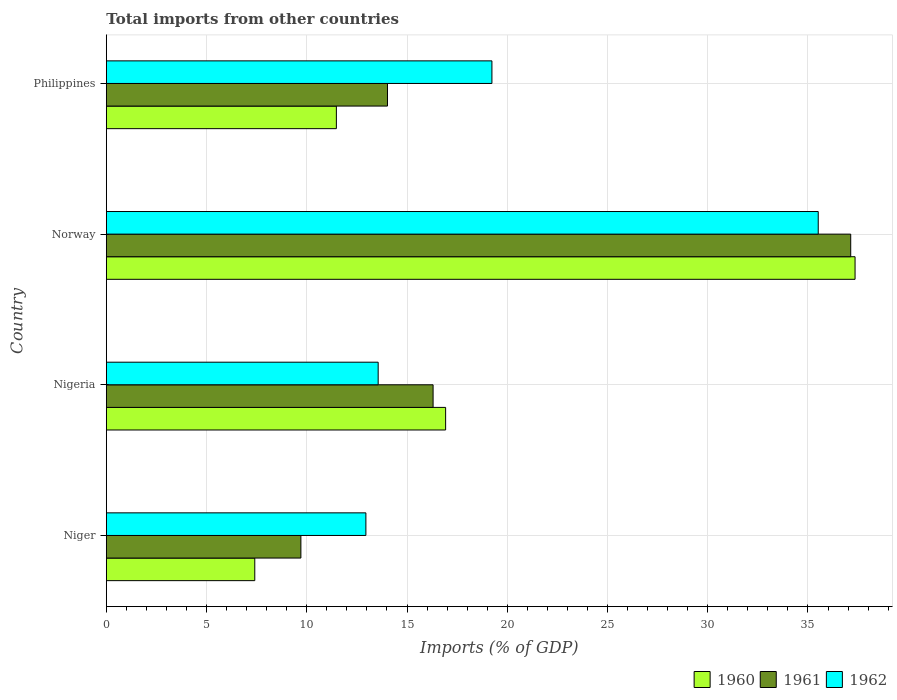How many bars are there on the 2nd tick from the top?
Keep it short and to the point. 3. What is the total imports in 1960 in Nigeria?
Your response must be concise. 16.92. Across all countries, what is the maximum total imports in 1960?
Your answer should be very brief. 37.35. Across all countries, what is the minimum total imports in 1962?
Ensure brevity in your answer.  12.95. In which country was the total imports in 1960 maximum?
Make the answer very short. Norway. In which country was the total imports in 1960 minimum?
Provide a succinct answer. Niger. What is the total total imports in 1962 in the graph?
Provide a short and direct response. 81.25. What is the difference between the total imports in 1960 in Nigeria and that in Norway?
Make the answer very short. -20.42. What is the difference between the total imports in 1960 in Philippines and the total imports in 1962 in Nigeria?
Ensure brevity in your answer.  -2.09. What is the average total imports in 1961 per country?
Keep it short and to the point. 19.29. What is the difference between the total imports in 1962 and total imports in 1960 in Nigeria?
Offer a very short reply. -3.36. What is the ratio of the total imports in 1961 in Niger to that in Norway?
Your answer should be compact. 0.26. Is the total imports in 1962 in Norway less than that in Philippines?
Make the answer very short. No. What is the difference between the highest and the second highest total imports in 1960?
Offer a terse response. 20.42. What is the difference between the highest and the lowest total imports in 1961?
Ensure brevity in your answer.  27.43. In how many countries, is the total imports in 1962 greater than the average total imports in 1962 taken over all countries?
Your answer should be very brief. 1. Is the sum of the total imports in 1961 in Nigeria and Norway greater than the maximum total imports in 1962 across all countries?
Your response must be concise. Yes. What does the 3rd bar from the top in Norway represents?
Make the answer very short. 1960. How many bars are there?
Your response must be concise. 12. How many countries are there in the graph?
Offer a very short reply. 4. Are the values on the major ticks of X-axis written in scientific E-notation?
Give a very brief answer. No. Does the graph contain any zero values?
Provide a succinct answer. No. How many legend labels are there?
Give a very brief answer. 3. How are the legend labels stacked?
Provide a succinct answer. Horizontal. What is the title of the graph?
Offer a terse response. Total imports from other countries. Does "2002" appear as one of the legend labels in the graph?
Make the answer very short. No. What is the label or title of the X-axis?
Ensure brevity in your answer.  Imports (% of GDP). What is the Imports (% of GDP) in 1960 in Niger?
Keep it short and to the point. 7.41. What is the Imports (% of GDP) in 1961 in Niger?
Your answer should be very brief. 9.71. What is the Imports (% of GDP) of 1962 in Niger?
Provide a succinct answer. 12.95. What is the Imports (% of GDP) in 1960 in Nigeria?
Your answer should be compact. 16.92. What is the Imports (% of GDP) of 1961 in Nigeria?
Provide a succinct answer. 16.3. What is the Imports (% of GDP) of 1962 in Nigeria?
Give a very brief answer. 13.56. What is the Imports (% of GDP) in 1960 in Norway?
Your response must be concise. 37.35. What is the Imports (% of GDP) in 1961 in Norway?
Provide a succinct answer. 37.13. What is the Imports (% of GDP) of 1962 in Norway?
Offer a terse response. 35.51. What is the Imports (% of GDP) of 1960 in Philippines?
Give a very brief answer. 11.48. What is the Imports (% of GDP) in 1961 in Philippines?
Provide a succinct answer. 14.02. What is the Imports (% of GDP) in 1962 in Philippines?
Your answer should be compact. 19.23. Across all countries, what is the maximum Imports (% of GDP) of 1960?
Offer a terse response. 37.35. Across all countries, what is the maximum Imports (% of GDP) of 1961?
Your response must be concise. 37.13. Across all countries, what is the maximum Imports (% of GDP) of 1962?
Give a very brief answer. 35.51. Across all countries, what is the minimum Imports (% of GDP) of 1960?
Your response must be concise. 7.41. Across all countries, what is the minimum Imports (% of GDP) of 1961?
Your answer should be very brief. 9.71. Across all countries, what is the minimum Imports (% of GDP) in 1962?
Give a very brief answer. 12.95. What is the total Imports (% of GDP) of 1960 in the graph?
Make the answer very short. 73.15. What is the total Imports (% of GDP) of 1961 in the graph?
Keep it short and to the point. 77.16. What is the total Imports (% of GDP) of 1962 in the graph?
Your answer should be very brief. 81.25. What is the difference between the Imports (% of GDP) of 1960 in Niger and that in Nigeria?
Make the answer very short. -9.52. What is the difference between the Imports (% of GDP) in 1961 in Niger and that in Nigeria?
Ensure brevity in your answer.  -6.59. What is the difference between the Imports (% of GDP) in 1962 in Niger and that in Nigeria?
Your answer should be very brief. -0.61. What is the difference between the Imports (% of GDP) in 1960 in Niger and that in Norway?
Your answer should be very brief. -29.94. What is the difference between the Imports (% of GDP) of 1961 in Niger and that in Norway?
Offer a terse response. -27.43. What is the difference between the Imports (% of GDP) of 1962 in Niger and that in Norway?
Offer a terse response. -22.56. What is the difference between the Imports (% of GDP) of 1960 in Niger and that in Philippines?
Your response must be concise. -4.07. What is the difference between the Imports (% of GDP) of 1961 in Niger and that in Philippines?
Make the answer very short. -4.32. What is the difference between the Imports (% of GDP) of 1962 in Niger and that in Philippines?
Provide a short and direct response. -6.29. What is the difference between the Imports (% of GDP) of 1960 in Nigeria and that in Norway?
Make the answer very short. -20.42. What is the difference between the Imports (% of GDP) of 1961 in Nigeria and that in Norway?
Offer a terse response. -20.83. What is the difference between the Imports (% of GDP) in 1962 in Nigeria and that in Norway?
Your response must be concise. -21.95. What is the difference between the Imports (% of GDP) in 1960 in Nigeria and that in Philippines?
Ensure brevity in your answer.  5.45. What is the difference between the Imports (% of GDP) in 1961 in Nigeria and that in Philippines?
Your answer should be very brief. 2.27. What is the difference between the Imports (% of GDP) in 1962 in Nigeria and that in Philippines?
Offer a very short reply. -5.67. What is the difference between the Imports (% of GDP) of 1960 in Norway and that in Philippines?
Make the answer very short. 25.87. What is the difference between the Imports (% of GDP) in 1961 in Norway and that in Philippines?
Provide a succinct answer. 23.11. What is the difference between the Imports (% of GDP) of 1962 in Norway and that in Philippines?
Your answer should be very brief. 16.28. What is the difference between the Imports (% of GDP) in 1960 in Niger and the Imports (% of GDP) in 1961 in Nigeria?
Provide a short and direct response. -8.89. What is the difference between the Imports (% of GDP) in 1960 in Niger and the Imports (% of GDP) in 1962 in Nigeria?
Provide a succinct answer. -6.16. What is the difference between the Imports (% of GDP) in 1961 in Niger and the Imports (% of GDP) in 1962 in Nigeria?
Your response must be concise. -3.85. What is the difference between the Imports (% of GDP) of 1960 in Niger and the Imports (% of GDP) of 1961 in Norway?
Make the answer very short. -29.73. What is the difference between the Imports (% of GDP) of 1960 in Niger and the Imports (% of GDP) of 1962 in Norway?
Offer a terse response. -28.11. What is the difference between the Imports (% of GDP) in 1961 in Niger and the Imports (% of GDP) in 1962 in Norway?
Give a very brief answer. -25.81. What is the difference between the Imports (% of GDP) of 1960 in Niger and the Imports (% of GDP) of 1961 in Philippines?
Offer a very short reply. -6.62. What is the difference between the Imports (% of GDP) of 1960 in Niger and the Imports (% of GDP) of 1962 in Philippines?
Offer a terse response. -11.83. What is the difference between the Imports (% of GDP) of 1961 in Niger and the Imports (% of GDP) of 1962 in Philippines?
Ensure brevity in your answer.  -9.53. What is the difference between the Imports (% of GDP) in 1960 in Nigeria and the Imports (% of GDP) in 1961 in Norway?
Make the answer very short. -20.21. What is the difference between the Imports (% of GDP) of 1960 in Nigeria and the Imports (% of GDP) of 1962 in Norway?
Offer a very short reply. -18.59. What is the difference between the Imports (% of GDP) of 1961 in Nigeria and the Imports (% of GDP) of 1962 in Norway?
Your response must be concise. -19.21. What is the difference between the Imports (% of GDP) in 1960 in Nigeria and the Imports (% of GDP) in 1961 in Philippines?
Ensure brevity in your answer.  2.9. What is the difference between the Imports (% of GDP) in 1960 in Nigeria and the Imports (% of GDP) in 1962 in Philippines?
Your response must be concise. -2.31. What is the difference between the Imports (% of GDP) of 1961 in Nigeria and the Imports (% of GDP) of 1962 in Philippines?
Keep it short and to the point. -2.93. What is the difference between the Imports (% of GDP) of 1960 in Norway and the Imports (% of GDP) of 1961 in Philippines?
Ensure brevity in your answer.  23.32. What is the difference between the Imports (% of GDP) in 1960 in Norway and the Imports (% of GDP) in 1962 in Philippines?
Offer a very short reply. 18.11. What is the difference between the Imports (% of GDP) in 1961 in Norway and the Imports (% of GDP) in 1962 in Philippines?
Ensure brevity in your answer.  17.9. What is the average Imports (% of GDP) in 1960 per country?
Your response must be concise. 18.29. What is the average Imports (% of GDP) of 1961 per country?
Ensure brevity in your answer.  19.29. What is the average Imports (% of GDP) of 1962 per country?
Give a very brief answer. 20.31. What is the difference between the Imports (% of GDP) of 1960 and Imports (% of GDP) of 1962 in Niger?
Give a very brief answer. -5.54. What is the difference between the Imports (% of GDP) of 1961 and Imports (% of GDP) of 1962 in Niger?
Your answer should be compact. -3.24. What is the difference between the Imports (% of GDP) of 1960 and Imports (% of GDP) of 1961 in Nigeria?
Provide a short and direct response. 0.63. What is the difference between the Imports (% of GDP) of 1960 and Imports (% of GDP) of 1962 in Nigeria?
Offer a very short reply. 3.36. What is the difference between the Imports (% of GDP) of 1961 and Imports (% of GDP) of 1962 in Nigeria?
Offer a terse response. 2.74. What is the difference between the Imports (% of GDP) in 1960 and Imports (% of GDP) in 1961 in Norway?
Your response must be concise. 0.22. What is the difference between the Imports (% of GDP) of 1960 and Imports (% of GDP) of 1962 in Norway?
Your response must be concise. 1.84. What is the difference between the Imports (% of GDP) of 1961 and Imports (% of GDP) of 1962 in Norway?
Your response must be concise. 1.62. What is the difference between the Imports (% of GDP) of 1960 and Imports (% of GDP) of 1961 in Philippines?
Your answer should be very brief. -2.55. What is the difference between the Imports (% of GDP) in 1960 and Imports (% of GDP) in 1962 in Philippines?
Your answer should be compact. -7.76. What is the difference between the Imports (% of GDP) in 1961 and Imports (% of GDP) in 1962 in Philippines?
Give a very brief answer. -5.21. What is the ratio of the Imports (% of GDP) in 1960 in Niger to that in Nigeria?
Your answer should be compact. 0.44. What is the ratio of the Imports (% of GDP) of 1961 in Niger to that in Nigeria?
Keep it short and to the point. 0.6. What is the ratio of the Imports (% of GDP) in 1962 in Niger to that in Nigeria?
Provide a short and direct response. 0.95. What is the ratio of the Imports (% of GDP) in 1960 in Niger to that in Norway?
Provide a short and direct response. 0.2. What is the ratio of the Imports (% of GDP) of 1961 in Niger to that in Norway?
Your answer should be very brief. 0.26. What is the ratio of the Imports (% of GDP) in 1962 in Niger to that in Norway?
Make the answer very short. 0.36. What is the ratio of the Imports (% of GDP) of 1960 in Niger to that in Philippines?
Make the answer very short. 0.65. What is the ratio of the Imports (% of GDP) of 1961 in Niger to that in Philippines?
Keep it short and to the point. 0.69. What is the ratio of the Imports (% of GDP) of 1962 in Niger to that in Philippines?
Give a very brief answer. 0.67. What is the ratio of the Imports (% of GDP) of 1960 in Nigeria to that in Norway?
Your answer should be compact. 0.45. What is the ratio of the Imports (% of GDP) in 1961 in Nigeria to that in Norway?
Your answer should be compact. 0.44. What is the ratio of the Imports (% of GDP) of 1962 in Nigeria to that in Norway?
Offer a very short reply. 0.38. What is the ratio of the Imports (% of GDP) in 1960 in Nigeria to that in Philippines?
Provide a short and direct response. 1.47. What is the ratio of the Imports (% of GDP) in 1961 in Nigeria to that in Philippines?
Give a very brief answer. 1.16. What is the ratio of the Imports (% of GDP) in 1962 in Nigeria to that in Philippines?
Give a very brief answer. 0.7. What is the ratio of the Imports (% of GDP) of 1960 in Norway to that in Philippines?
Your answer should be very brief. 3.25. What is the ratio of the Imports (% of GDP) of 1961 in Norway to that in Philippines?
Your answer should be compact. 2.65. What is the ratio of the Imports (% of GDP) of 1962 in Norway to that in Philippines?
Your response must be concise. 1.85. What is the difference between the highest and the second highest Imports (% of GDP) of 1960?
Your answer should be compact. 20.42. What is the difference between the highest and the second highest Imports (% of GDP) of 1961?
Offer a very short reply. 20.83. What is the difference between the highest and the second highest Imports (% of GDP) in 1962?
Make the answer very short. 16.28. What is the difference between the highest and the lowest Imports (% of GDP) of 1960?
Offer a terse response. 29.94. What is the difference between the highest and the lowest Imports (% of GDP) of 1961?
Your response must be concise. 27.43. What is the difference between the highest and the lowest Imports (% of GDP) of 1962?
Your response must be concise. 22.56. 